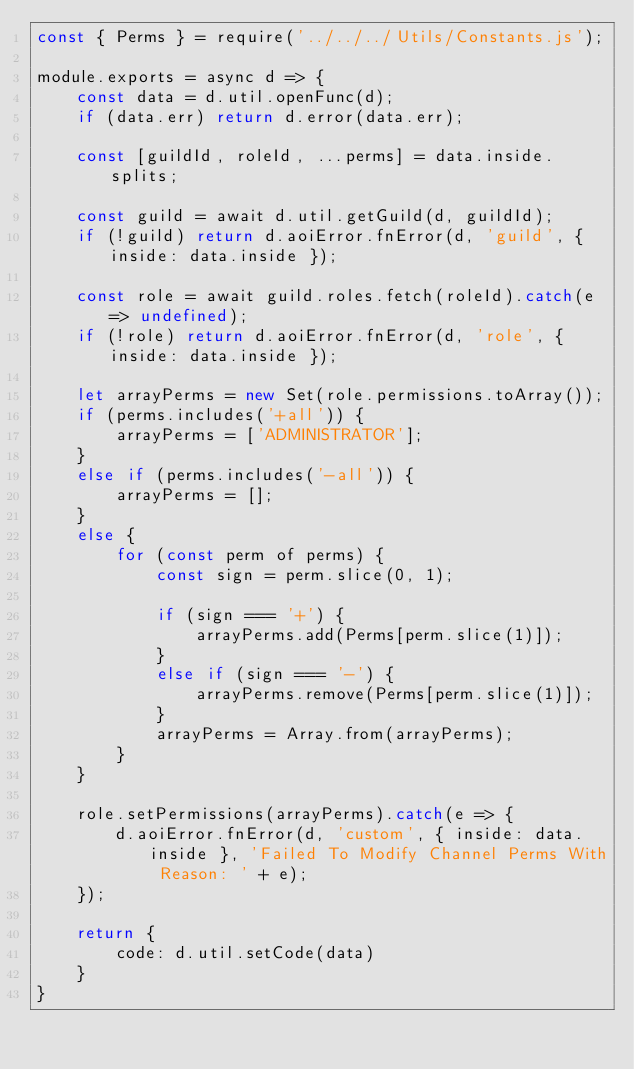<code> <loc_0><loc_0><loc_500><loc_500><_JavaScript_>const { Perms } = require('../../../Utils/Constants.js');

module.exports = async d => {
    const data = d.util.openFunc(d);
    if (data.err) return d.error(data.err);

    const [guildId, roleId, ...perms] = data.inside.splits;

    const guild = await d.util.getGuild(d, guildId);
    if (!guild) return d.aoiError.fnError(d, 'guild', { inside: data.inside });

    const role = await guild.roles.fetch(roleId).catch(e => undefined);
    if (!role) return d.aoiError.fnError(d, 'role', { inside: data.inside });

    let arrayPerms = new Set(role.permissions.toArray());
    if (perms.includes('+all')) {
        arrayPerms = ['ADMINISTRATOR'];
    }
    else if (perms.includes('-all')) {
        arrayPerms = [];
    }
    else {
        for (const perm of perms) {
            const sign = perm.slice(0, 1);

            if (sign === '+') {
                arrayPerms.add(Perms[perm.slice(1)]);
            }
            else if (sign === '-') {
                arrayPerms.remove(Perms[perm.slice(1)]);
            }
            arrayPerms = Array.from(arrayPerms);
        }
    }

    role.setPermissions(arrayPerms).catch(e => {
        d.aoiError.fnError(d, 'custom', { inside: data.inside }, 'Failed To Modify Channel Perms With Reason: ' + e);
    });

    return {
        code: d.util.setCode(data)
    }
}</code> 